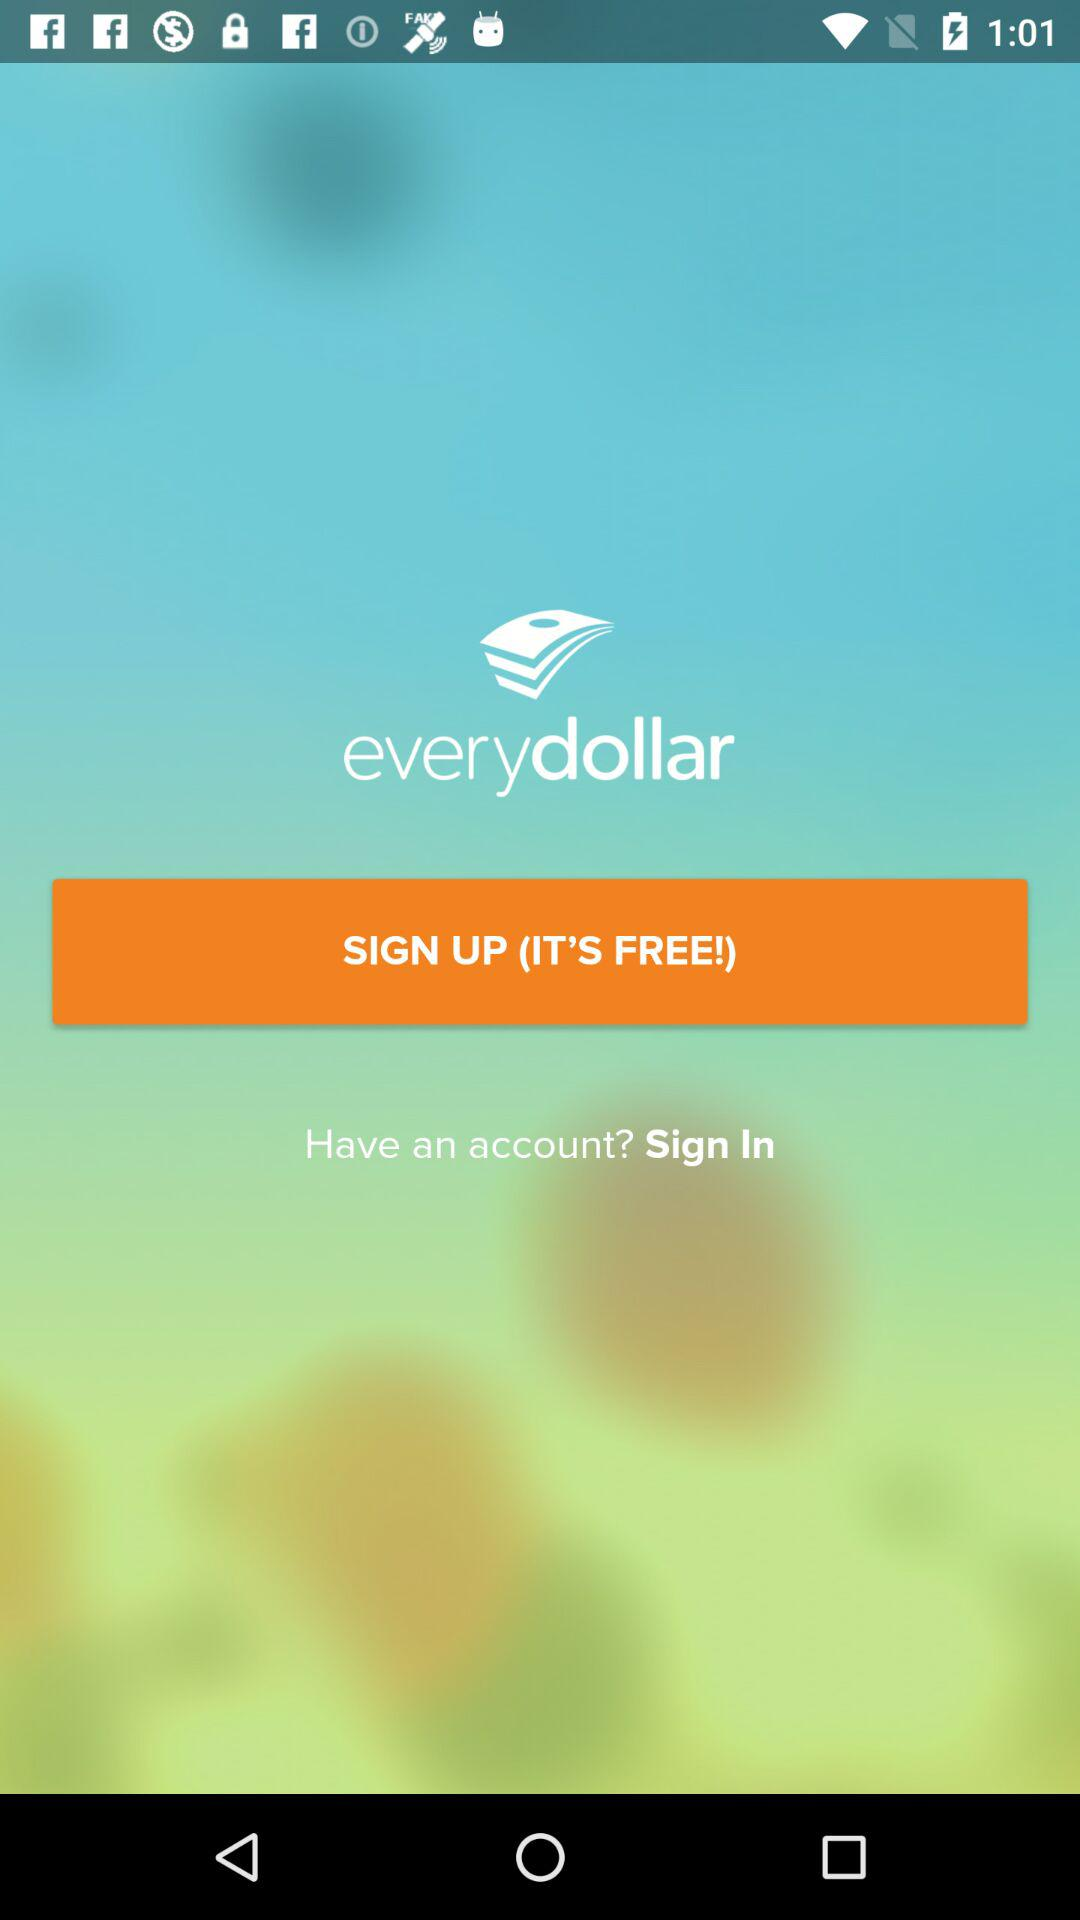What is the application name? The application name is "everydollar". 